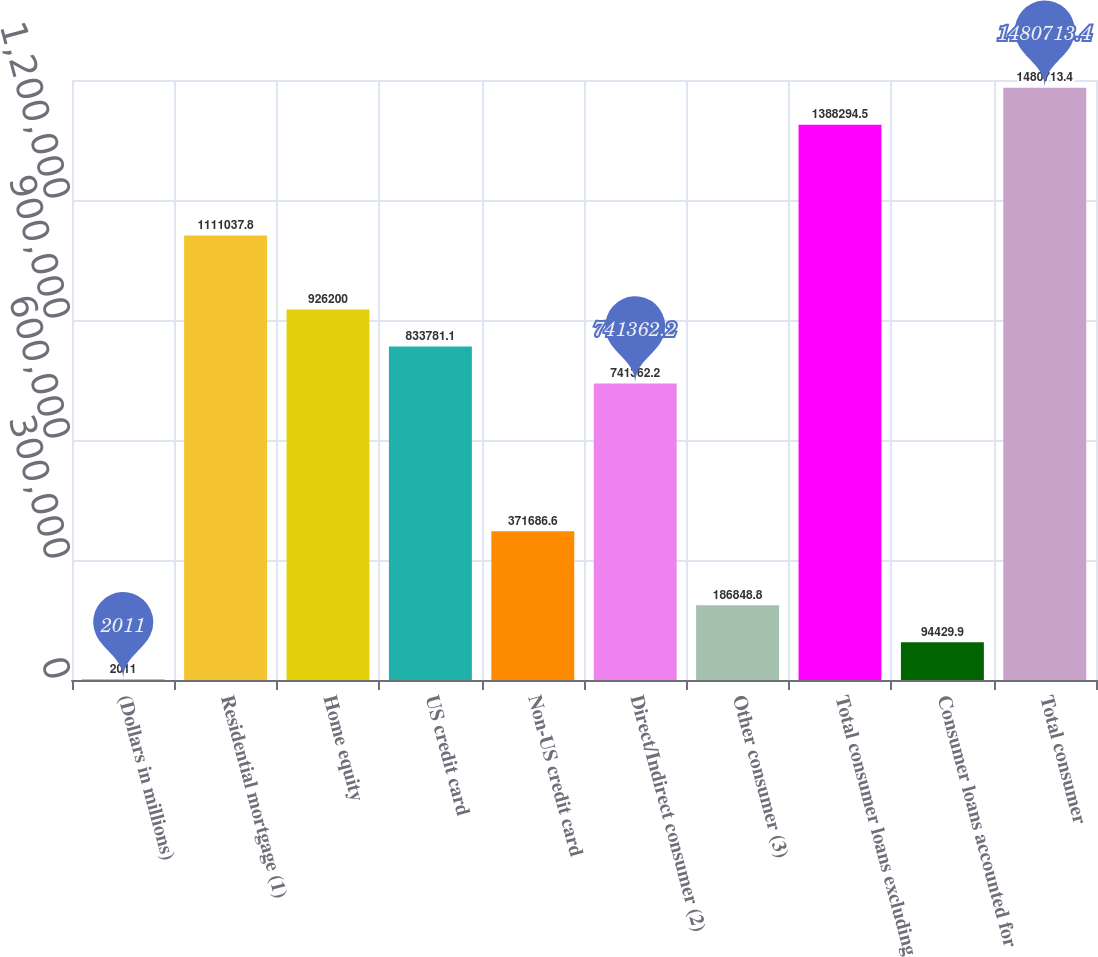Convert chart. <chart><loc_0><loc_0><loc_500><loc_500><bar_chart><fcel>(Dollars in millions)<fcel>Residential mortgage (1)<fcel>Home equity<fcel>US credit card<fcel>Non-US credit card<fcel>Direct/Indirect consumer (2)<fcel>Other consumer (3)<fcel>Total consumer loans excluding<fcel>Consumer loans accounted for<fcel>Total consumer<nl><fcel>2011<fcel>1.11104e+06<fcel>926200<fcel>833781<fcel>371687<fcel>741362<fcel>186849<fcel>1.38829e+06<fcel>94429.9<fcel>1.48071e+06<nl></chart> 